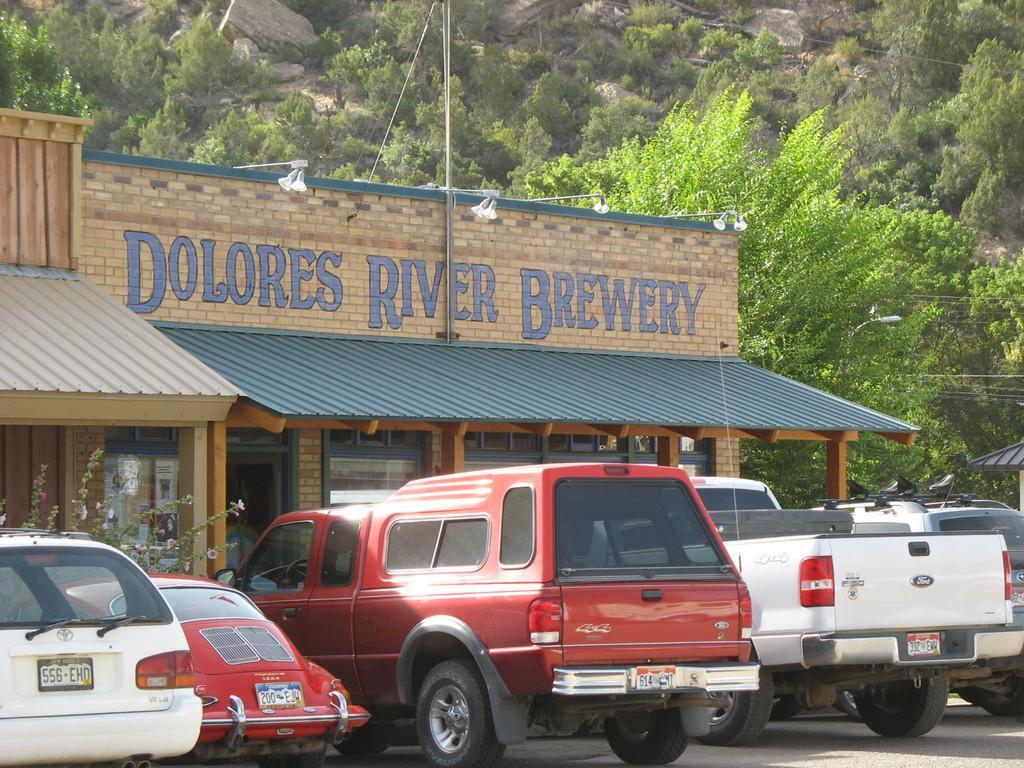How would you summarize this image in a sentence or two? In this picture I can observe some vehicles parked on the road in front of a building. I can observe white, red and blue color vehicles on the road. There is a brown color building. In the background I can observe some trees on the hill. 